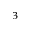<formula> <loc_0><loc_0><loc_500><loc_500>^ { 3 }</formula> 